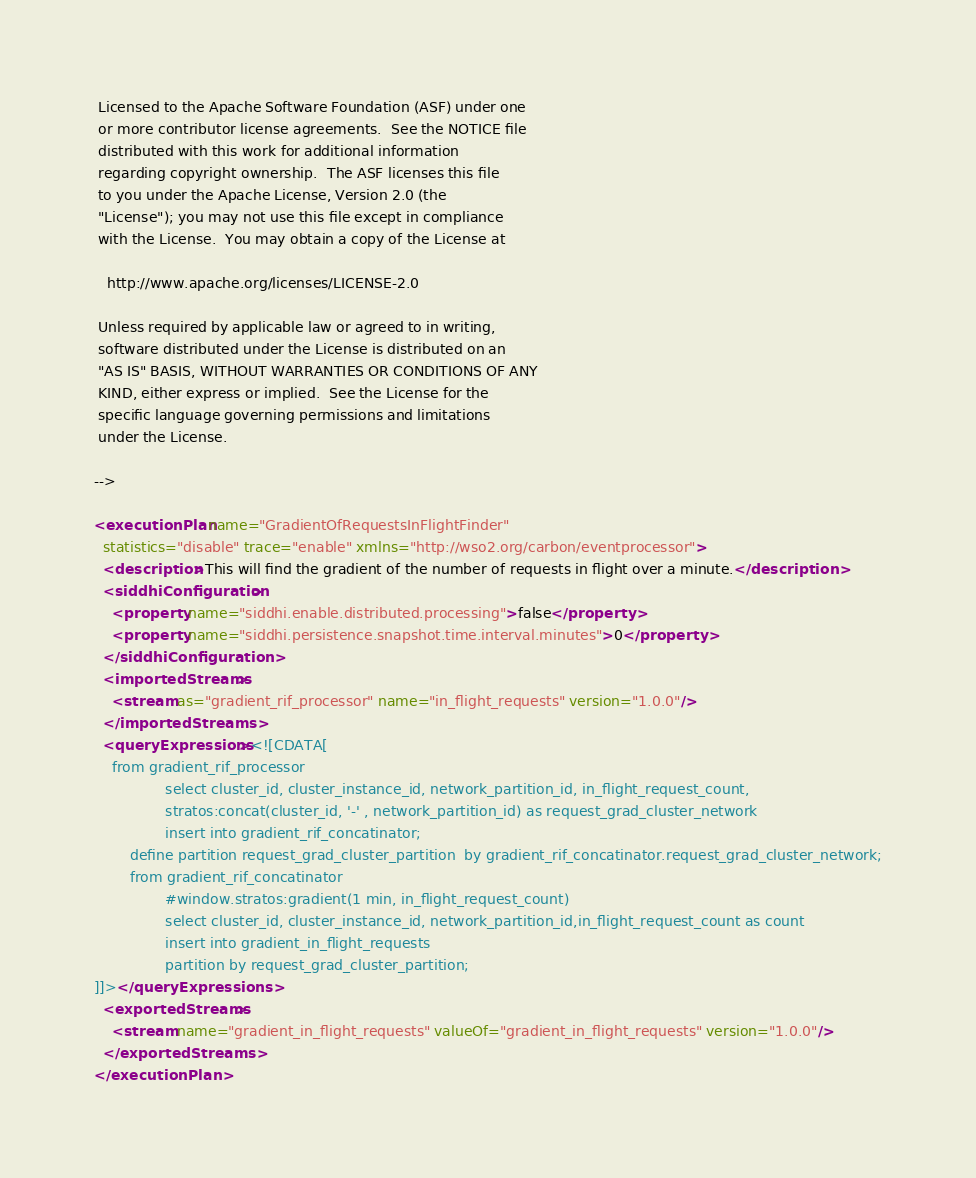<code> <loc_0><loc_0><loc_500><loc_500><_XML_> Licensed to the Apache Software Foundation (ASF) under one
 or more contributor license agreements.  See the NOTICE file
 distributed with this work for additional information
 regarding copyright ownership.  The ASF licenses this file
 to you under the Apache License, Version 2.0 (the
 "License"); you may not use this file except in compliance
 with the License.  You may obtain a copy of the License at

   http://www.apache.org/licenses/LICENSE-2.0

 Unless required by applicable law or agreed to in writing,
 software distributed under the License is distributed on an
 "AS IS" BASIS, WITHOUT WARRANTIES OR CONDITIONS OF ANY
 KIND, either express or implied.  See the License for the
 specific language governing permissions and limitations
 under the License.

-->

<executionPlan name="GradientOfRequestsInFlightFinder"
  statistics="disable" trace="enable" xmlns="http://wso2.org/carbon/eventprocessor">
  <description>This will find the gradient of the number of requests in flight over a minute.</description>
  <siddhiConfiguration>
    <property name="siddhi.enable.distributed.processing">false</property>
    <property name="siddhi.persistence.snapshot.time.interval.minutes">0</property>
  </siddhiConfiguration>
  <importedStreams>
    <stream as="gradient_rif_processor" name="in_flight_requests" version="1.0.0"/>
  </importedStreams>
  <queryExpressions><![CDATA[
	from gradient_rif_processor 
                select cluster_id, cluster_instance_id, network_partition_id, in_flight_request_count,
                stratos:concat(cluster_id, '-' , network_partition_id) as request_grad_cluster_network 
                insert into gradient_rif_concatinator;
        define partition request_grad_cluster_partition  by gradient_rif_concatinator.request_grad_cluster_network;
        from gradient_rif_concatinator
                #window.stratos:gradient(1 min, in_flight_request_count)
                select cluster_id, cluster_instance_id, network_partition_id,in_flight_request_count as count
                insert into gradient_in_flight_requests 
                partition by request_grad_cluster_partition;
]]></queryExpressions>
  <exportedStreams>
    <stream name="gradient_in_flight_requests" valueOf="gradient_in_flight_requests" version="1.0.0"/>
  </exportedStreams>
</executionPlan>
</code> 